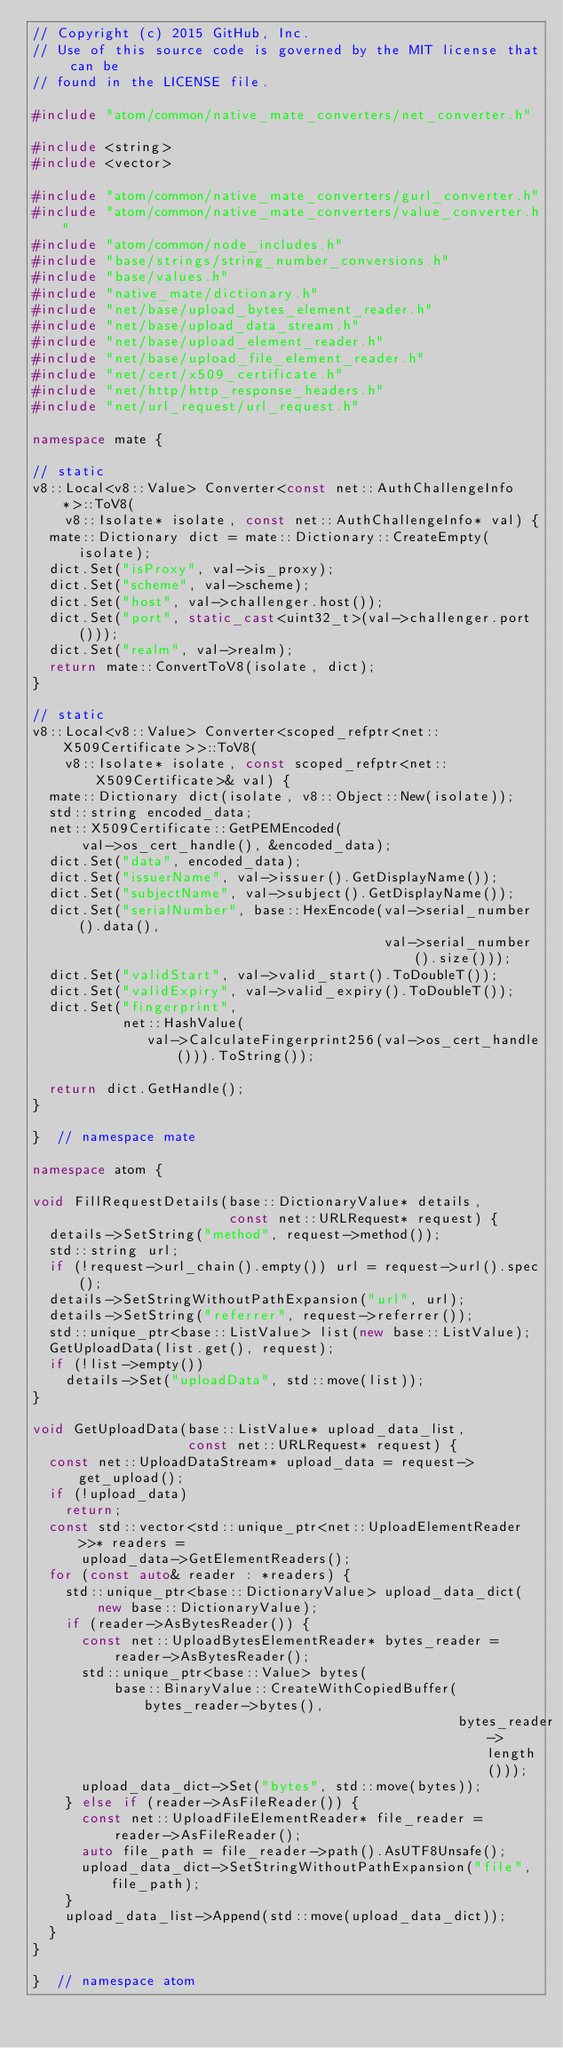Convert code to text. <code><loc_0><loc_0><loc_500><loc_500><_C++_>// Copyright (c) 2015 GitHub, Inc.
// Use of this source code is governed by the MIT license that can be
// found in the LICENSE file.

#include "atom/common/native_mate_converters/net_converter.h"

#include <string>
#include <vector>

#include "atom/common/native_mate_converters/gurl_converter.h"
#include "atom/common/native_mate_converters/value_converter.h"
#include "atom/common/node_includes.h"
#include "base/strings/string_number_conversions.h"
#include "base/values.h"
#include "native_mate/dictionary.h"
#include "net/base/upload_bytes_element_reader.h"
#include "net/base/upload_data_stream.h"
#include "net/base/upload_element_reader.h"
#include "net/base/upload_file_element_reader.h"
#include "net/cert/x509_certificate.h"
#include "net/http/http_response_headers.h"
#include "net/url_request/url_request.h"

namespace mate {

// static
v8::Local<v8::Value> Converter<const net::AuthChallengeInfo*>::ToV8(
    v8::Isolate* isolate, const net::AuthChallengeInfo* val) {
  mate::Dictionary dict = mate::Dictionary::CreateEmpty(isolate);
  dict.Set("isProxy", val->is_proxy);
  dict.Set("scheme", val->scheme);
  dict.Set("host", val->challenger.host());
  dict.Set("port", static_cast<uint32_t>(val->challenger.port()));
  dict.Set("realm", val->realm);
  return mate::ConvertToV8(isolate, dict);
}

// static
v8::Local<v8::Value> Converter<scoped_refptr<net::X509Certificate>>::ToV8(
    v8::Isolate* isolate, const scoped_refptr<net::X509Certificate>& val) {
  mate::Dictionary dict(isolate, v8::Object::New(isolate));
  std::string encoded_data;
  net::X509Certificate::GetPEMEncoded(
      val->os_cert_handle(), &encoded_data);
  dict.Set("data", encoded_data);
  dict.Set("issuerName", val->issuer().GetDisplayName());
  dict.Set("subjectName", val->subject().GetDisplayName());
  dict.Set("serialNumber", base::HexEncode(val->serial_number().data(),
                                           val->serial_number().size()));
  dict.Set("validStart", val->valid_start().ToDoubleT());
  dict.Set("validExpiry", val->valid_expiry().ToDoubleT());
  dict.Set("fingerprint",
           net::HashValue(
              val->CalculateFingerprint256(val->os_cert_handle())).ToString());

  return dict.GetHandle();
}

}  // namespace mate

namespace atom {

void FillRequestDetails(base::DictionaryValue* details,
                        const net::URLRequest* request) {
  details->SetString("method", request->method());
  std::string url;
  if (!request->url_chain().empty()) url = request->url().spec();
  details->SetStringWithoutPathExpansion("url", url);
  details->SetString("referrer", request->referrer());
  std::unique_ptr<base::ListValue> list(new base::ListValue);
  GetUploadData(list.get(), request);
  if (!list->empty())
    details->Set("uploadData", std::move(list));
}

void GetUploadData(base::ListValue* upload_data_list,
                   const net::URLRequest* request) {
  const net::UploadDataStream* upload_data = request->get_upload();
  if (!upload_data)
    return;
  const std::vector<std::unique_ptr<net::UploadElementReader>>* readers =
      upload_data->GetElementReaders();
  for (const auto& reader : *readers) {
    std::unique_ptr<base::DictionaryValue> upload_data_dict(
        new base::DictionaryValue);
    if (reader->AsBytesReader()) {
      const net::UploadBytesElementReader* bytes_reader =
          reader->AsBytesReader();
      std::unique_ptr<base::Value> bytes(
          base::BinaryValue::CreateWithCopiedBuffer(bytes_reader->bytes(),
                                                    bytes_reader->length()));
      upload_data_dict->Set("bytes", std::move(bytes));
    } else if (reader->AsFileReader()) {
      const net::UploadFileElementReader* file_reader =
          reader->AsFileReader();
      auto file_path = file_reader->path().AsUTF8Unsafe();
      upload_data_dict->SetStringWithoutPathExpansion("file", file_path);
    }
    upload_data_list->Append(std::move(upload_data_dict));
  }
}

}  // namespace atom
</code> 